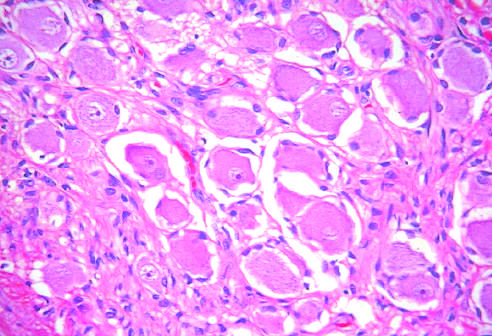do small nests of epithelial cells and myxoid stroma forming cartilage and bone contain mature cells from endodermal, mesodermal, and ectodermal lines?
Answer the question using a single word or phrase. No 